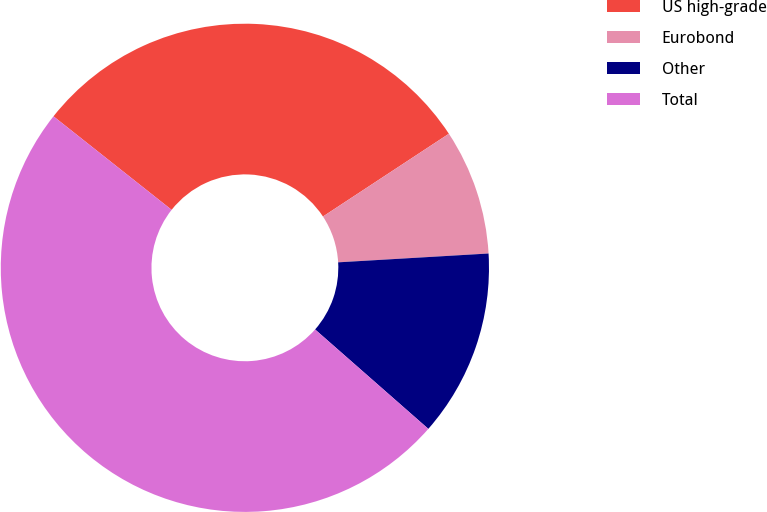Convert chart to OTSL. <chart><loc_0><loc_0><loc_500><loc_500><pie_chart><fcel>US high-grade<fcel>Eurobond<fcel>Other<fcel>Total<nl><fcel>30.09%<fcel>8.32%<fcel>12.4%<fcel>49.19%<nl></chart> 